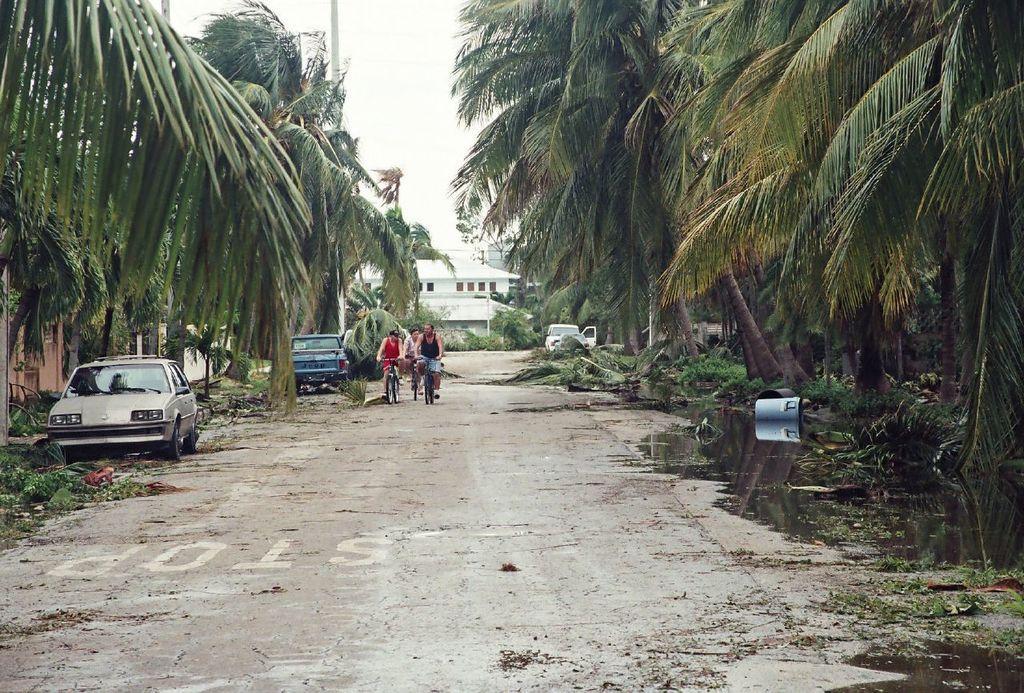How would you summarize this image in a sentence or two? In this image there are three man riding bicycle on a road and there are cars, on either side of the road there are trees and there is a water on the road, in the background there is a house. 